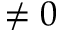<formula> <loc_0><loc_0><loc_500><loc_500>\neq 0</formula> 